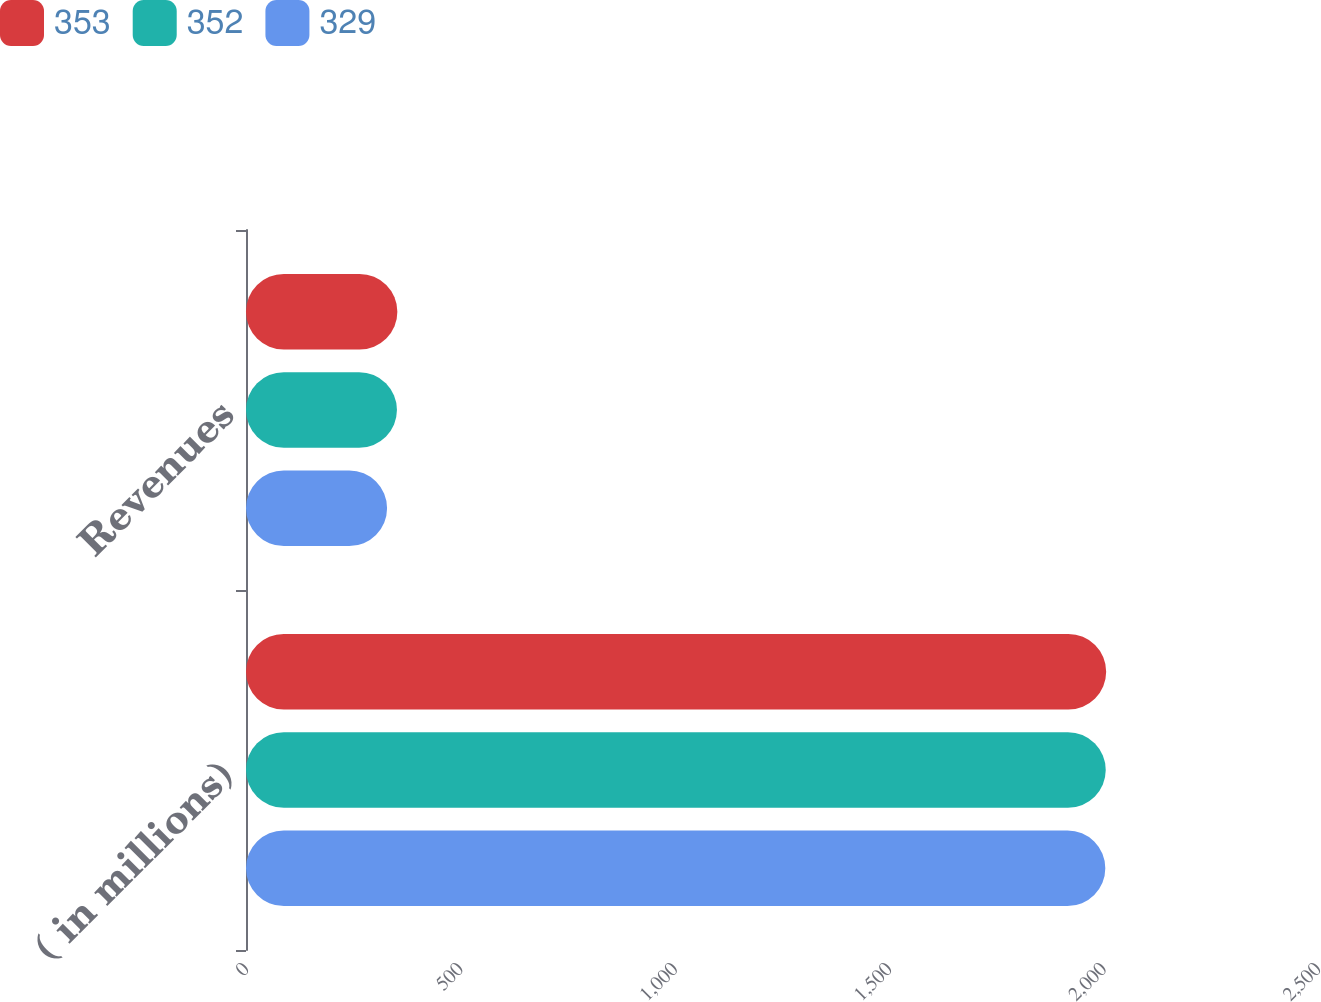Convert chart. <chart><loc_0><loc_0><loc_500><loc_500><stacked_bar_chart><ecel><fcel>( in millions)<fcel>Revenues<nl><fcel>353<fcel>2006<fcel>353<nl><fcel>352<fcel>2005<fcel>352<nl><fcel>329<fcel>2004<fcel>329<nl></chart> 